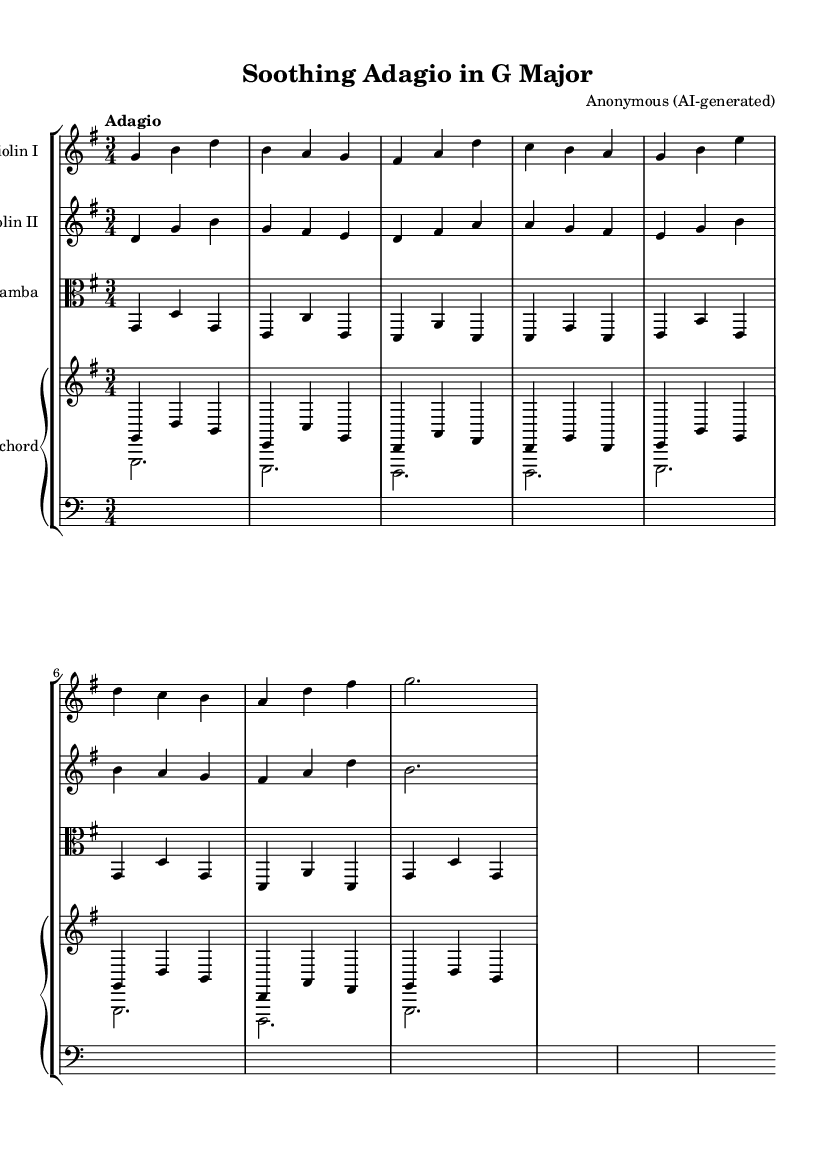What is the key signature of this music? The key signature, indicated at the beginning of the music, shows one sharp, which corresponds to G major.
Answer: G major What is the time signature of this music? The time signature is found near the beginning of the score. It is represented as 3/4, meaning there are three beats in each measure, and the quarter note gets one beat.
Answer: 3/4 What is the tempo marking for this music? The tempo marking, found above the score, states "Adagio," which indicates a slow tempo.
Answer: Adagio How many instruments are in this composition? By examining the score layout, we can count the number of staves. There are four instrument staves: two violins, one viola da gamba, and one for harpsichord (which is a piano staff).
Answer: Four What is the texture of the music? Given that there are multiple independent lines with harmonic support from the harpsichord while the violins and viola play melodic lines, this indicates a polyphonic texture common in Baroque music.
Answer: Polyphonic What is the role of the harpsichord in this piece? The harpsichord provides both melodic and harmonic support, indicated by its dual staff arrangement that utilizes chords and bass notes, characteristic of the Baroque tradition.
Answer: Harmonic support What is the overall mood suggested by the music? The slow tempo indicated by "Adagio," along with the smooth melodic lines and gentle harmonies, conveys a calming and reflective mood typical for relaxation.
Answer: Calming 